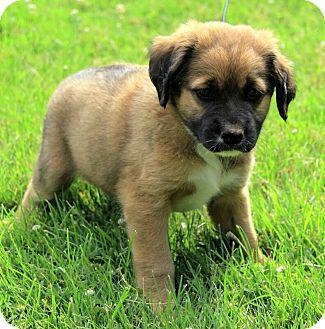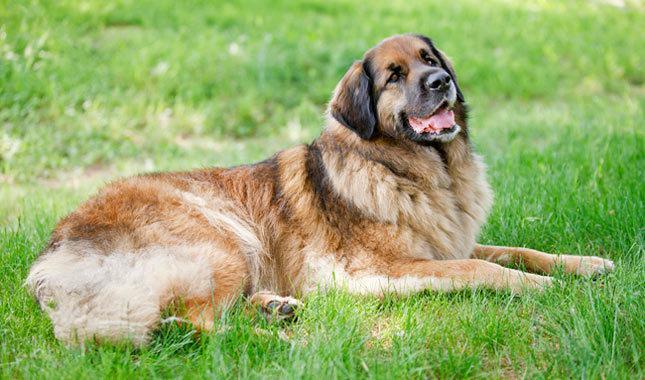The first image is the image on the left, the second image is the image on the right. Given the left and right images, does the statement "One image shows a puppy and the other shows an adult dog." hold true? Answer yes or no. Yes. 